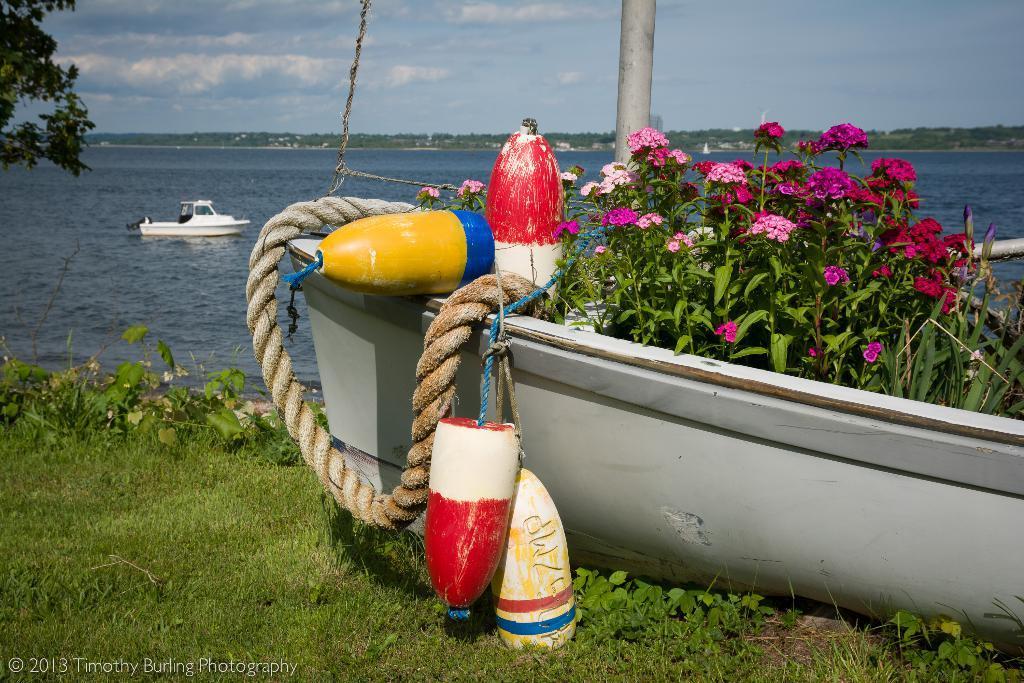Describe this image in one or two sentences. As we can see in the image there is grass, boats, tree, water, sky, clouds, rope, plants and flowers. 